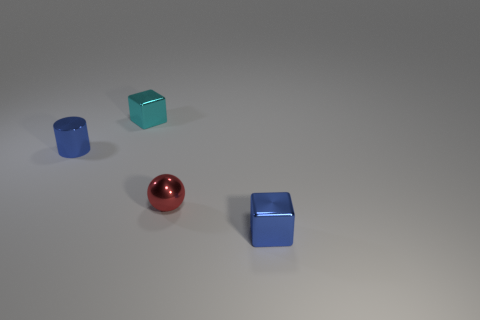Add 4 big yellow blocks. How many objects exist? 8 Add 2 tiny blue things. How many tiny blue things are left? 4 Add 2 tiny purple metal objects. How many tiny purple metal objects exist? 2 Subtract 0 red cylinders. How many objects are left? 4 Subtract all cylinders. How many objects are left? 3 Subtract all large matte things. Subtract all tiny cubes. How many objects are left? 2 